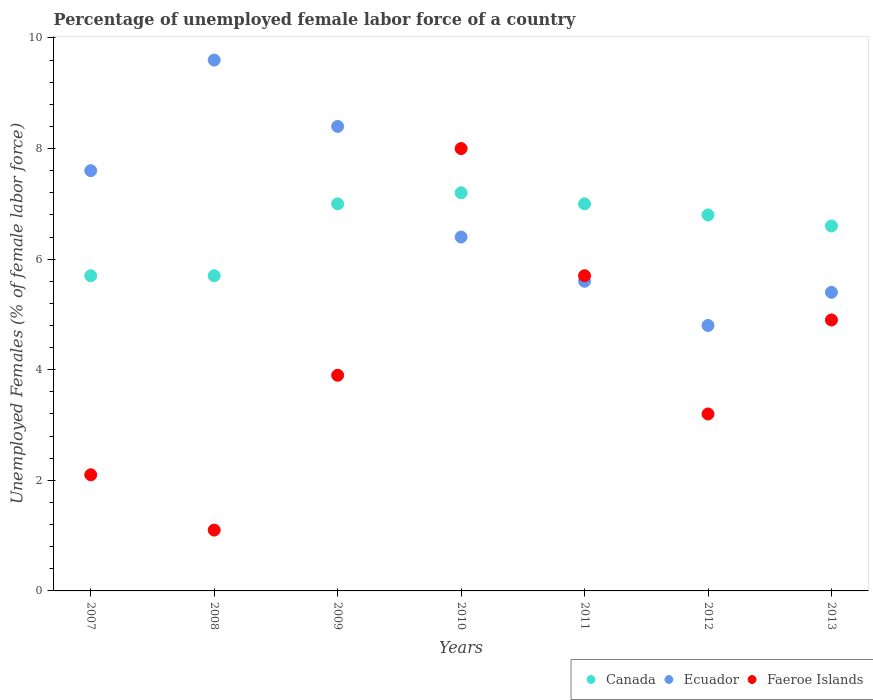What is the percentage of unemployed female labor force in Canada in 2010?
Give a very brief answer. 7.2. Across all years, what is the maximum percentage of unemployed female labor force in Canada?
Provide a succinct answer. 7.2. Across all years, what is the minimum percentage of unemployed female labor force in Canada?
Give a very brief answer. 5.7. In which year was the percentage of unemployed female labor force in Canada minimum?
Your answer should be compact. 2007. What is the total percentage of unemployed female labor force in Canada in the graph?
Your response must be concise. 46. What is the difference between the percentage of unemployed female labor force in Ecuador in 2009 and that in 2011?
Your answer should be compact. 2.8. What is the difference between the percentage of unemployed female labor force in Ecuador in 2007 and the percentage of unemployed female labor force in Faeroe Islands in 2012?
Provide a short and direct response. 4.4. What is the average percentage of unemployed female labor force in Canada per year?
Offer a very short reply. 6.57. In the year 2010, what is the difference between the percentage of unemployed female labor force in Ecuador and percentage of unemployed female labor force in Canada?
Give a very brief answer. -0.8. What is the ratio of the percentage of unemployed female labor force in Canada in 2007 to that in 2013?
Offer a terse response. 0.86. What is the difference between the highest and the second highest percentage of unemployed female labor force in Canada?
Make the answer very short. 0.2. What is the difference between the highest and the lowest percentage of unemployed female labor force in Faeroe Islands?
Offer a very short reply. 6.9. In how many years, is the percentage of unemployed female labor force in Ecuador greater than the average percentage of unemployed female labor force in Ecuador taken over all years?
Your answer should be compact. 3. Does the percentage of unemployed female labor force in Faeroe Islands monotonically increase over the years?
Ensure brevity in your answer.  No. How many years are there in the graph?
Your answer should be very brief. 7. What is the difference between two consecutive major ticks on the Y-axis?
Offer a terse response. 2. Does the graph contain any zero values?
Give a very brief answer. No. Does the graph contain grids?
Your answer should be compact. No. Where does the legend appear in the graph?
Provide a succinct answer. Bottom right. How many legend labels are there?
Give a very brief answer. 3. How are the legend labels stacked?
Make the answer very short. Horizontal. What is the title of the graph?
Make the answer very short. Percentage of unemployed female labor force of a country. Does "Czech Republic" appear as one of the legend labels in the graph?
Make the answer very short. No. What is the label or title of the Y-axis?
Your answer should be very brief. Unemployed Females (% of female labor force). What is the Unemployed Females (% of female labor force) of Canada in 2007?
Offer a very short reply. 5.7. What is the Unemployed Females (% of female labor force) in Ecuador in 2007?
Give a very brief answer. 7.6. What is the Unemployed Females (% of female labor force) of Faeroe Islands in 2007?
Keep it short and to the point. 2.1. What is the Unemployed Females (% of female labor force) in Canada in 2008?
Your answer should be compact. 5.7. What is the Unemployed Females (% of female labor force) in Ecuador in 2008?
Provide a succinct answer. 9.6. What is the Unemployed Females (% of female labor force) in Faeroe Islands in 2008?
Offer a terse response. 1.1. What is the Unemployed Females (% of female labor force) in Canada in 2009?
Provide a succinct answer. 7. What is the Unemployed Females (% of female labor force) of Ecuador in 2009?
Offer a very short reply. 8.4. What is the Unemployed Females (% of female labor force) in Faeroe Islands in 2009?
Provide a succinct answer. 3.9. What is the Unemployed Females (% of female labor force) in Canada in 2010?
Provide a succinct answer. 7.2. What is the Unemployed Females (% of female labor force) of Ecuador in 2010?
Make the answer very short. 6.4. What is the Unemployed Females (% of female labor force) of Faeroe Islands in 2010?
Offer a terse response. 8. What is the Unemployed Females (% of female labor force) in Ecuador in 2011?
Offer a terse response. 5.6. What is the Unemployed Females (% of female labor force) in Faeroe Islands in 2011?
Ensure brevity in your answer.  5.7. What is the Unemployed Females (% of female labor force) in Canada in 2012?
Make the answer very short. 6.8. What is the Unemployed Females (% of female labor force) of Ecuador in 2012?
Make the answer very short. 4.8. What is the Unemployed Females (% of female labor force) of Faeroe Islands in 2012?
Keep it short and to the point. 3.2. What is the Unemployed Females (% of female labor force) of Canada in 2013?
Your answer should be very brief. 6.6. What is the Unemployed Females (% of female labor force) in Ecuador in 2013?
Give a very brief answer. 5.4. What is the Unemployed Females (% of female labor force) in Faeroe Islands in 2013?
Your answer should be very brief. 4.9. Across all years, what is the maximum Unemployed Females (% of female labor force) in Canada?
Make the answer very short. 7.2. Across all years, what is the maximum Unemployed Females (% of female labor force) of Ecuador?
Make the answer very short. 9.6. Across all years, what is the maximum Unemployed Females (% of female labor force) of Faeroe Islands?
Keep it short and to the point. 8. Across all years, what is the minimum Unemployed Females (% of female labor force) of Canada?
Your answer should be compact. 5.7. Across all years, what is the minimum Unemployed Females (% of female labor force) of Ecuador?
Provide a succinct answer. 4.8. Across all years, what is the minimum Unemployed Females (% of female labor force) of Faeroe Islands?
Give a very brief answer. 1.1. What is the total Unemployed Females (% of female labor force) in Canada in the graph?
Offer a terse response. 46. What is the total Unemployed Females (% of female labor force) of Ecuador in the graph?
Ensure brevity in your answer.  47.8. What is the total Unemployed Females (% of female labor force) of Faeroe Islands in the graph?
Make the answer very short. 28.9. What is the difference between the Unemployed Females (% of female labor force) in Canada in 2007 and that in 2008?
Give a very brief answer. 0. What is the difference between the Unemployed Females (% of female labor force) in Ecuador in 2007 and that in 2008?
Give a very brief answer. -2. What is the difference between the Unemployed Females (% of female labor force) in Faeroe Islands in 2007 and that in 2008?
Offer a very short reply. 1. What is the difference between the Unemployed Females (% of female labor force) in Ecuador in 2007 and that in 2010?
Provide a short and direct response. 1.2. What is the difference between the Unemployed Females (% of female labor force) of Faeroe Islands in 2007 and that in 2010?
Give a very brief answer. -5.9. What is the difference between the Unemployed Females (% of female labor force) of Canada in 2007 and that in 2011?
Make the answer very short. -1.3. What is the difference between the Unemployed Females (% of female labor force) of Faeroe Islands in 2007 and that in 2011?
Keep it short and to the point. -3.6. What is the difference between the Unemployed Females (% of female labor force) of Canada in 2007 and that in 2012?
Your answer should be very brief. -1.1. What is the difference between the Unemployed Females (% of female labor force) in Ecuador in 2007 and that in 2013?
Give a very brief answer. 2.2. What is the difference between the Unemployed Females (% of female labor force) in Canada in 2008 and that in 2009?
Keep it short and to the point. -1.3. What is the difference between the Unemployed Females (% of female labor force) of Ecuador in 2008 and that in 2009?
Your answer should be very brief. 1.2. What is the difference between the Unemployed Females (% of female labor force) in Faeroe Islands in 2008 and that in 2009?
Offer a very short reply. -2.8. What is the difference between the Unemployed Females (% of female labor force) of Canada in 2008 and that in 2010?
Your answer should be compact. -1.5. What is the difference between the Unemployed Females (% of female labor force) in Ecuador in 2008 and that in 2010?
Give a very brief answer. 3.2. What is the difference between the Unemployed Females (% of female labor force) in Canada in 2008 and that in 2011?
Provide a short and direct response. -1.3. What is the difference between the Unemployed Females (% of female labor force) of Ecuador in 2008 and that in 2011?
Offer a very short reply. 4. What is the difference between the Unemployed Females (% of female labor force) of Faeroe Islands in 2008 and that in 2011?
Offer a very short reply. -4.6. What is the difference between the Unemployed Females (% of female labor force) in Ecuador in 2008 and that in 2012?
Offer a terse response. 4.8. What is the difference between the Unemployed Females (% of female labor force) in Faeroe Islands in 2008 and that in 2012?
Your response must be concise. -2.1. What is the difference between the Unemployed Females (% of female labor force) in Canada in 2008 and that in 2013?
Your response must be concise. -0.9. What is the difference between the Unemployed Females (% of female labor force) in Canada in 2009 and that in 2011?
Provide a succinct answer. 0. What is the difference between the Unemployed Females (% of female labor force) of Ecuador in 2009 and that in 2012?
Your answer should be very brief. 3.6. What is the difference between the Unemployed Females (% of female labor force) in Faeroe Islands in 2009 and that in 2012?
Provide a short and direct response. 0.7. What is the difference between the Unemployed Females (% of female labor force) of Canada in 2009 and that in 2013?
Ensure brevity in your answer.  0.4. What is the difference between the Unemployed Females (% of female labor force) of Ecuador in 2009 and that in 2013?
Your answer should be very brief. 3. What is the difference between the Unemployed Females (% of female labor force) of Faeroe Islands in 2009 and that in 2013?
Keep it short and to the point. -1. What is the difference between the Unemployed Females (% of female labor force) in Canada in 2010 and that in 2011?
Your answer should be compact. 0.2. What is the difference between the Unemployed Females (% of female labor force) in Faeroe Islands in 2010 and that in 2011?
Keep it short and to the point. 2.3. What is the difference between the Unemployed Females (% of female labor force) of Canada in 2010 and that in 2012?
Make the answer very short. 0.4. What is the difference between the Unemployed Females (% of female labor force) in Faeroe Islands in 2010 and that in 2012?
Offer a very short reply. 4.8. What is the difference between the Unemployed Females (% of female labor force) of Ecuador in 2010 and that in 2013?
Your response must be concise. 1. What is the difference between the Unemployed Females (% of female labor force) in Ecuador in 2011 and that in 2012?
Give a very brief answer. 0.8. What is the difference between the Unemployed Females (% of female labor force) of Faeroe Islands in 2011 and that in 2012?
Your answer should be compact. 2.5. What is the difference between the Unemployed Females (% of female labor force) of Faeroe Islands in 2011 and that in 2013?
Make the answer very short. 0.8. What is the difference between the Unemployed Females (% of female labor force) of Canada in 2012 and that in 2013?
Offer a very short reply. 0.2. What is the difference between the Unemployed Females (% of female labor force) of Canada in 2007 and the Unemployed Females (% of female labor force) of Ecuador in 2008?
Offer a terse response. -3.9. What is the difference between the Unemployed Females (% of female labor force) of Canada in 2007 and the Unemployed Females (% of female labor force) of Faeroe Islands in 2008?
Make the answer very short. 4.6. What is the difference between the Unemployed Females (% of female labor force) in Canada in 2007 and the Unemployed Females (% of female labor force) in Ecuador in 2009?
Your answer should be compact. -2.7. What is the difference between the Unemployed Females (% of female labor force) in Canada in 2007 and the Unemployed Females (% of female labor force) in Ecuador in 2010?
Ensure brevity in your answer.  -0.7. What is the difference between the Unemployed Females (% of female labor force) of Canada in 2007 and the Unemployed Females (% of female labor force) of Faeroe Islands in 2010?
Your answer should be compact. -2.3. What is the difference between the Unemployed Females (% of female labor force) of Canada in 2007 and the Unemployed Females (% of female labor force) of Faeroe Islands in 2011?
Provide a succinct answer. 0. What is the difference between the Unemployed Females (% of female labor force) in Canada in 2007 and the Unemployed Females (% of female labor force) in Ecuador in 2012?
Offer a terse response. 0.9. What is the difference between the Unemployed Females (% of female labor force) of Canada in 2007 and the Unemployed Females (% of female labor force) of Ecuador in 2013?
Ensure brevity in your answer.  0.3. What is the difference between the Unemployed Females (% of female labor force) of Canada in 2007 and the Unemployed Females (% of female labor force) of Faeroe Islands in 2013?
Offer a terse response. 0.8. What is the difference between the Unemployed Females (% of female labor force) in Ecuador in 2007 and the Unemployed Females (% of female labor force) in Faeroe Islands in 2013?
Your answer should be very brief. 2.7. What is the difference between the Unemployed Females (% of female labor force) of Canada in 2008 and the Unemployed Females (% of female labor force) of Ecuador in 2010?
Make the answer very short. -0.7. What is the difference between the Unemployed Females (% of female labor force) in Canada in 2008 and the Unemployed Females (% of female labor force) in Ecuador in 2011?
Make the answer very short. 0.1. What is the difference between the Unemployed Females (% of female labor force) in Ecuador in 2008 and the Unemployed Females (% of female labor force) in Faeroe Islands in 2011?
Your answer should be compact. 3.9. What is the difference between the Unemployed Females (% of female labor force) of Canada in 2008 and the Unemployed Females (% of female labor force) of Ecuador in 2012?
Offer a very short reply. 0.9. What is the difference between the Unemployed Females (% of female labor force) of Canada in 2008 and the Unemployed Females (% of female labor force) of Faeroe Islands in 2012?
Your answer should be very brief. 2.5. What is the difference between the Unemployed Females (% of female labor force) of Canada in 2008 and the Unemployed Females (% of female labor force) of Faeroe Islands in 2013?
Offer a terse response. 0.8. What is the difference between the Unemployed Females (% of female labor force) of Canada in 2009 and the Unemployed Females (% of female labor force) of Ecuador in 2010?
Your response must be concise. 0.6. What is the difference between the Unemployed Females (% of female labor force) of Canada in 2009 and the Unemployed Females (% of female labor force) of Faeroe Islands in 2010?
Provide a succinct answer. -1. What is the difference between the Unemployed Females (% of female labor force) of Ecuador in 2009 and the Unemployed Females (% of female labor force) of Faeroe Islands in 2011?
Ensure brevity in your answer.  2.7. What is the difference between the Unemployed Females (% of female labor force) in Canada in 2009 and the Unemployed Females (% of female labor force) in Ecuador in 2012?
Keep it short and to the point. 2.2. What is the difference between the Unemployed Females (% of female labor force) in Ecuador in 2009 and the Unemployed Females (% of female labor force) in Faeroe Islands in 2012?
Offer a terse response. 5.2. What is the difference between the Unemployed Females (% of female labor force) in Canada in 2010 and the Unemployed Females (% of female labor force) in Ecuador in 2011?
Provide a short and direct response. 1.6. What is the difference between the Unemployed Females (% of female labor force) in Canada in 2010 and the Unemployed Females (% of female labor force) in Faeroe Islands in 2011?
Your answer should be compact. 1.5. What is the difference between the Unemployed Females (% of female labor force) of Canada in 2010 and the Unemployed Females (% of female labor force) of Faeroe Islands in 2013?
Give a very brief answer. 2.3. What is the difference between the Unemployed Females (% of female labor force) in Ecuador in 2010 and the Unemployed Females (% of female labor force) in Faeroe Islands in 2013?
Give a very brief answer. 1.5. What is the difference between the Unemployed Females (% of female labor force) of Canada in 2011 and the Unemployed Females (% of female labor force) of Faeroe Islands in 2012?
Your answer should be very brief. 3.8. What is the difference between the Unemployed Females (% of female labor force) of Ecuador in 2011 and the Unemployed Females (% of female labor force) of Faeroe Islands in 2012?
Provide a short and direct response. 2.4. What is the difference between the Unemployed Females (% of female labor force) in Canada in 2011 and the Unemployed Females (% of female labor force) in Ecuador in 2013?
Give a very brief answer. 1.6. What is the difference between the Unemployed Females (% of female labor force) in Canada in 2011 and the Unemployed Females (% of female labor force) in Faeroe Islands in 2013?
Offer a very short reply. 2.1. What is the difference between the Unemployed Females (% of female labor force) of Ecuador in 2011 and the Unemployed Females (% of female labor force) of Faeroe Islands in 2013?
Your response must be concise. 0.7. What is the difference between the Unemployed Females (% of female labor force) of Canada in 2012 and the Unemployed Females (% of female labor force) of Ecuador in 2013?
Offer a very short reply. 1.4. What is the average Unemployed Females (% of female labor force) in Canada per year?
Offer a terse response. 6.57. What is the average Unemployed Females (% of female labor force) in Ecuador per year?
Provide a short and direct response. 6.83. What is the average Unemployed Females (% of female labor force) of Faeroe Islands per year?
Offer a very short reply. 4.13. In the year 2007, what is the difference between the Unemployed Females (% of female labor force) in Canada and Unemployed Females (% of female labor force) in Faeroe Islands?
Your response must be concise. 3.6. In the year 2007, what is the difference between the Unemployed Females (% of female labor force) in Ecuador and Unemployed Females (% of female labor force) in Faeroe Islands?
Provide a succinct answer. 5.5. In the year 2008, what is the difference between the Unemployed Females (% of female labor force) in Canada and Unemployed Females (% of female labor force) in Ecuador?
Your answer should be very brief. -3.9. In the year 2008, what is the difference between the Unemployed Females (% of female labor force) in Canada and Unemployed Females (% of female labor force) in Faeroe Islands?
Provide a short and direct response. 4.6. In the year 2008, what is the difference between the Unemployed Females (% of female labor force) in Ecuador and Unemployed Females (% of female labor force) in Faeroe Islands?
Ensure brevity in your answer.  8.5. In the year 2009, what is the difference between the Unemployed Females (% of female labor force) in Canada and Unemployed Females (% of female labor force) in Ecuador?
Offer a terse response. -1.4. In the year 2009, what is the difference between the Unemployed Females (% of female labor force) in Ecuador and Unemployed Females (% of female labor force) in Faeroe Islands?
Keep it short and to the point. 4.5. In the year 2010, what is the difference between the Unemployed Females (% of female labor force) of Canada and Unemployed Females (% of female labor force) of Ecuador?
Offer a terse response. 0.8. In the year 2010, what is the difference between the Unemployed Females (% of female labor force) in Canada and Unemployed Females (% of female labor force) in Faeroe Islands?
Make the answer very short. -0.8. In the year 2010, what is the difference between the Unemployed Females (% of female labor force) in Ecuador and Unemployed Females (% of female labor force) in Faeroe Islands?
Give a very brief answer. -1.6. In the year 2011, what is the difference between the Unemployed Females (% of female labor force) of Canada and Unemployed Females (% of female labor force) of Ecuador?
Provide a short and direct response. 1.4. In the year 2011, what is the difference between the Unemployed Females (% of female labor force) of Canada and Unemployed Females (% of female labor force) of Faeroe Islands?
Give a very brief answer. 1.3. In the year 2012, what is the difference between the Unemployed Females (% of female labor force) of Canada and Unemployed Females (% of female labor force) of Faeroe Islands?
Provide a succinct answer. 3.6. In the year 2012, what is the difference between the Unemployed Females (% of female labor force) in Ecuador and Unemployed Females (% of female labor force) in Faeroe Islands?
Your answer should be very brief. 1.6. In the year 2013, what is the difference between the Unemployed Females (% of female labor force) of Canada and Unemployed Females (% of female labor force) of Ecuador?
Your answer should be very brief. 1.2. In the year 2013, what is the difference between the Unemployed Females (% of female labor force) in Canada and Unemployed Females (% of female labor force) in Faeroe Islands?
Offer a very short reply. 1.7. In the year 2013, what is the difference between the Unemployed Females (% of female labor force) in Ecuador and Unemployed Females (% of female labor force) in Faeroe Islands?
Your answer should be compact. 0.5. What is the ratio of the Unemployed Females (% of female labor force) in Canada in 2007 to that in 2008?
Your answer should be compact. 1. What is the ratio of the Unemployed Females (% of female labor force) of Ecuador in 2007 to that in 2008?
Offer a very short reply. 0.79. What is the ratio of the Unemployed Females (% of female labor force) in Faeroe Islands in 2007 to that in 2008?
Keep it short and to the point. 1.91. What is the ratio of the Unemployed Females (% of female labor force) in Canada in 2007 to that in 2009?
Make the answer very short. 0.81. What is the ratio of the Unemployed Females (% of female labor force) in Ecuador in 2007 to that in 2009?
Your answer should be compact. 0.9. What is the ratio of the Unemployed Females (% of female labor force) in Faeroe Islands in 2007 to that in 2009?
Your response must be concise. 0.54. What is the ratio of the Unemployed Females (% of female labor force) in Canada in 2007 to that in 2010?
Give a very brief answer. 0.79. What is the ratio of the Unemployed Females (% of female labor force) of Ecuador in 2007 to that in 2010?
Your answer should be compact. 1.19. What is the ratio of the Unemployed Females (% of female labor force) in Faeroe Islands in 2007 to that in 2010?
Offer a very short reply. 0.26. What is the ratio of the Unemployed Females (% of female labor force) of Canada in 2007 to that in 2011?
Your answer should be compact. 0.81. What is the ratio of the Unemployed Females (% of female labor force) of Ecuador in 2007 to that in 2011?
Provide a short and direct response. 1.36. What is the ratio of the Unemployed Females (% of female labor force) in Faeroe Islands in 2007 to that in 2011?
Make the answer very short. 0.37. What is the ratio of the Unemployed Females (% of female labor force) of Canada in 2007 to that in 2012?
Keep it short and to the point. 0.84. What is the ratio of the Unemployed Females (% of female labor force) of Ecuador in 2007 to that in 2012?
Keep it short and to the point. 1.58. What is the ratio of the Unemployed Females (% of female labor force) of Faeroe Islands in 2007 to that in 2012?
Offer a terse response. 0.66. What is the ratio of the Unemployed Females (% of female labor force) of Canada in 2007 to that in 2013?
Your answer should be compact. 0.86. What is the ratio of the Unemployed Females (% of female labor force) in Ecuador in 2007 to that in 2013?
Your answer should be compact. 1.41. What is the ratio of the Unemployed Females (% of female labor force) in Faeroe Islands in 2007 to that in 2013?
Give a very brief answer. 0.43. What is the ratio of the Unemployed Females (% of female labor force) of Canada in 2008 to that in 2009?
Your response must be concise. 0.81. What is the ratio of the Unemployed Females (% of female labor force) of Ecuador in 2008 to that in 2009?
Offer a very short reply. 1.14. What is the ratio of the Unemployed Females (% of female labor force) of Faeroe Islands in 2008 to that in 2009?
Offer a terse response. 0.28. What is the ratio of the Unemployed Females (% of female labor force) of Canada in 2008 to that in 2010?
Offer a terse response. 0.79. What is the ratio of the Unemployed Females (% of female labor force) of Faeroe Islands in 2008 to that in 2010?
Make the answer very short. 0.14. What is the ratio of the Unemployed Females (% of female labor force) in Canada in 2008 to that in 2011?
Your answer should be compact. 0.81. What is the ratio of the Unemployed Females (% of female labor force) in Ecuador in 2008 to that in 2011?
Offer a terse response. 1.71. What is the ratio of the Unemployed Females (% of female labor force) of Faeroe Islands in 2008 to that in 2011?
Make the answer very short. 0.19. What is the ratio of the Unemployed Females (% of female labor force) in Canada in 2008 to that in 2012?
Your answer should be compact. 0.84. What is the ratio of the Unemployed Females (% of female labor force) in Ecuador in 2008 to that in 2012?
Ensure brevity in your answer.  2. What is the ratio of the Unemployed Females (% of female labor force) of Faeroe Islands in 2008 to that in 2012?
Offer a very short reply. 0.34. What is the ratio of the Unemployed Females (% of female labor force) of Canada in 2008 to that in 2013?
Your answer should be very brief. 0.86. What is the ratio of the Unemployed Females (% of female labor force) in Ecuador in 2008 to that in 2013?
Offer a very short reply. 1.78. What is the ratio of the Unemployed Females (% of female labor force) in Faeroe Islands in 2008 to that in 2013?
Keep it short and to the point. 0.22. What is the ratio of the Unemployed Females (% of female labor force) of Canada in 2009 to that in 2010?
Give a very brief answer. 0.97. What is the ratio of the Unemployed Females (% of female labor force) in Ecuador in 2009 to that in 2010?
Offer a very short reply. 1.31. What is the ratio of the Unemployed Females (% of female labor force) of Faeroe Islands in 2009 to that in 2010?
Offer a very short reply. 0.49. What is the ratio of the Unemployed Females (% of female labor force) in Canada in 2009 to that in 2011?
Provide a short and direct response. 1. What is the ratio of the Unemployed Females (% of female labor force) in Ecuador in 2009 to that in 2011?
Provide a succinct answer. 1.5. What is the ratio of the Unemployed Females (% of female labor force) of Faeroe Islands in 2009 to that in 2011?
Keep it short and to the point. 0.68. What is the ratio of the Unemployed Females (% of female labor force) of Canada in 2009 to that in 2012?
Your response must be concise. 1.03. What is the ratio of the Unemployed Females (% of female labor force) in Ecuador in 2009 to that in 2012?
Ensure brevity in your answer.  1.75. What is the ratio of the Unemployed Females (% of female labor force) in Faeroe Islands in 2009 to that in 2012?
Make the answer very short. 1.22. What is the ratio of the Unemployed Females (% of female labor force) in Canada in 2009 to that in 2013?
Ensure brevity in your answer.  1.06. What is the ratio of the Unemployed Females (% of female labor force) of Ecuador in 2009 to that in 2013?
Your answer should be compact. 1.56. What is the ratio of the Unemployed Females (% of female labor force) of Faeroe Islands in 2009 to that in 2013?
Offer a very short reply. 0.8. What is the ratio of the Unemployed Females (% of female labor force) in Canada in 2010 to that in 2011?
Make the answer very short. 1.03. What is the ratio of the Unemployed Females (% of female labor force) of Faeroe Islands in 2010 to that in 2011?
Keep it short and to the point. 1.4. What is the ratio of the Unemployed Females (% of female labor force) in Canada in 2010 to that in 2012?
Ensure brevity in your answer.  1.06. What is the ratio of the Unemployed Females (% of female labor force) in Canada in 2010 to that in 2013?
Your answer should be very brief. 1.09. What is the ratio of the Unemployed Females (% of female labor force) of Ecuador in 2010 to that in 2013?
Provide a short and direct response. 1.19. What is the ratio of the Unemployed Females (% of female labor force) in Faeroe Islands in 2010 to that in 2013?
Offer a terse response. 1.63. What is the ratio of the Unemployed Females (% of female labor force) in Canada in 2011 to that in 2012?
Give a very brief answer. 1.03. What is the ratio of the Unemployed Females (% of female labor force) in Ecuador in 2011 to that in 2012?
Keep it short and to the point. 1.17. What is the ratio of the Unemployed Females (% of female labor force) in Faeroe Islands in 2011 to that in 2012?
Ensure brevity in your answer.  1.78. What is the ratio of the Unemployed Females (% of female labor force) in Canada in 2011 to that in 2013?
Provide a short and direct response. 1.06. What is the ratio of the Unemployed Females (% of female labor force) in Faeroe Islands in 2011 to that in 2013?
Ensure brevity in your answer.  1.16. What is the ratio of the Unemployed Females (% of female labor force) in Canada in 2012 to that in 2013?
Offer a terse response. 1.03. What is the ratio of the Unemployed Females (% of female labor force) of Faeroe Islands in 2012 to that in 2013?
Your answer should be compact. 0.65. What is the difference between the highest and the second highest Unemployed Females (% of female labor force) in Canada?
Your response must be concise. 0.2. What is the difference between the highest and the second highest Unemployed Females (% of female labor force) of Faeroe Islands?
Your answer should be very brief. 2.3. What is the difference between the highest and the lowest Unemployed Females (% of female labor force) in Faeroe Islands?
Give a very brief answer. 6.9. 